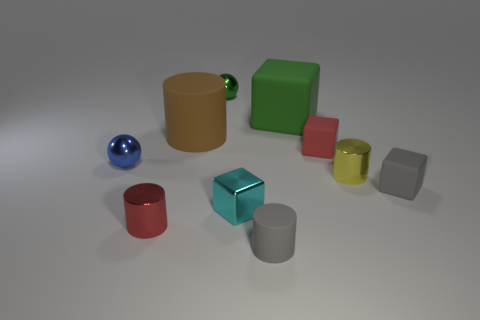Can you tell me the colors of the objects in the image? Certainly! In the image, there's a range of colored objects: a yellow cylinder, a green cube, a red cup, a teal cube, a grey cube, a silver cylinder, a gold cup, and a blue sphere. 